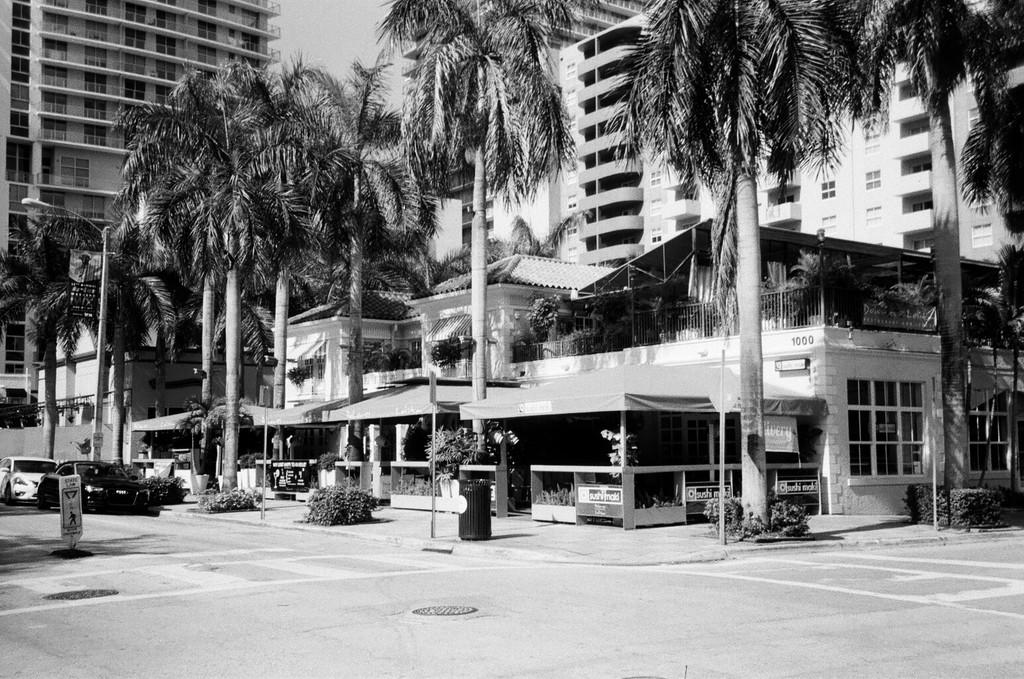What is the main feature of the image? There is a road in the image. What can be seen on the road? There are vehicles parked on the road. What type of natural elements are present in the image? There are trees and plants in the image. What can be seen in the distance? There are houses and buildings in the background of the image. How many birds with wings can be seen flying over the road in the image? There are no birds with wings visible in the image. What is the aftermath of the accident that occurred on the road in the image? There is no mention of an accident in the image, so it is not possible to describe the aftermath. 